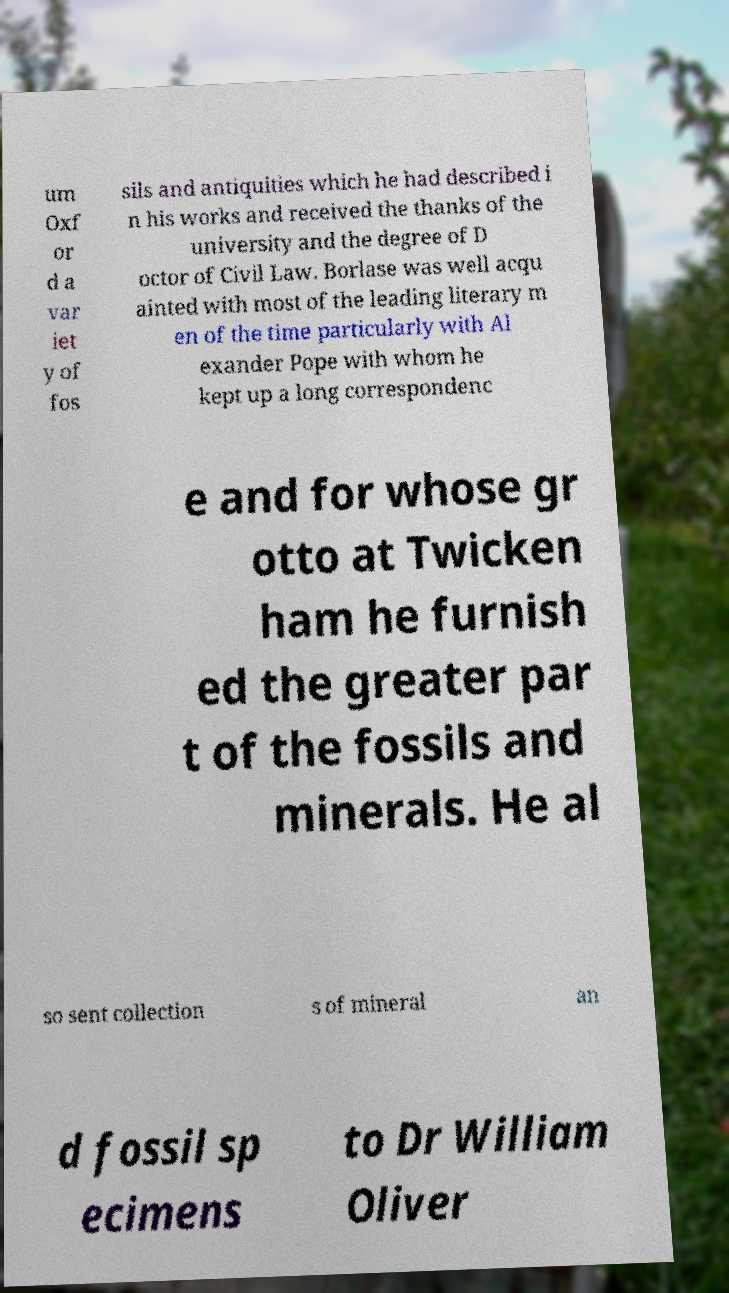Can you read and provide the text displayed in the image?This photo seems to have some interesting text. Can you extract and type it out for me? um Oxf or d a var iet y of fos sils and antiquities which he had described i n his works and received the thanks of the university and the degree of D octor of Civil Law. Borlase was well acqu ainted with most of the leading literary m en of the time particularly with Al exander Pope with whom he kept up a long correspondenc e and for whose gr otto at Twicken ham he furnish ed the greater par t of the fossils and minerals. He al so sent collection s of mineral an d fossil sp ecimens to Dr William Oliver 